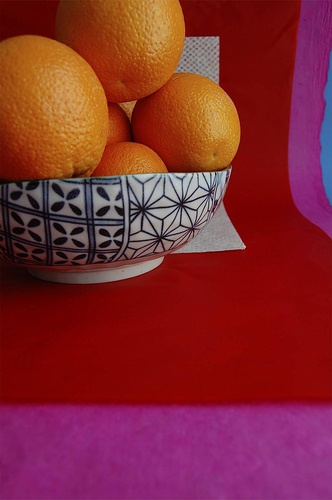Describe the objects in this image and their specific colors. I can see orange in maroon, red, and tan tones, bowl in maroon, black, darkgray, and gray tones, and orange in maroon, red, orange, and tan tones in this image. 